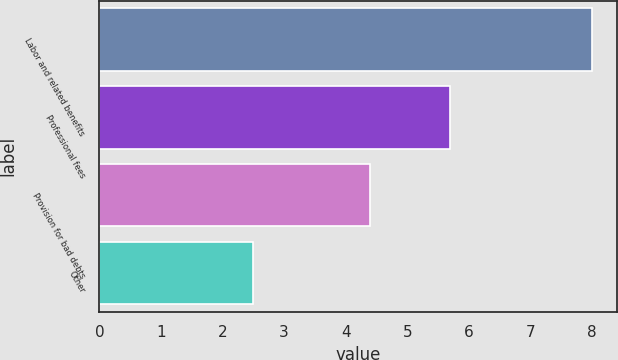Convert chart to OTSL. <chart><loc_0><loc_0><loc_500><loc_500><bar_chart><fcel>Labor and related benefits<fcel>Professional fees<fcel>Provision for bad debts<fcel>Other<nl><fcel>8<fcel>5.7<fcel>4.4<fcel>2.5<nl></chart> 